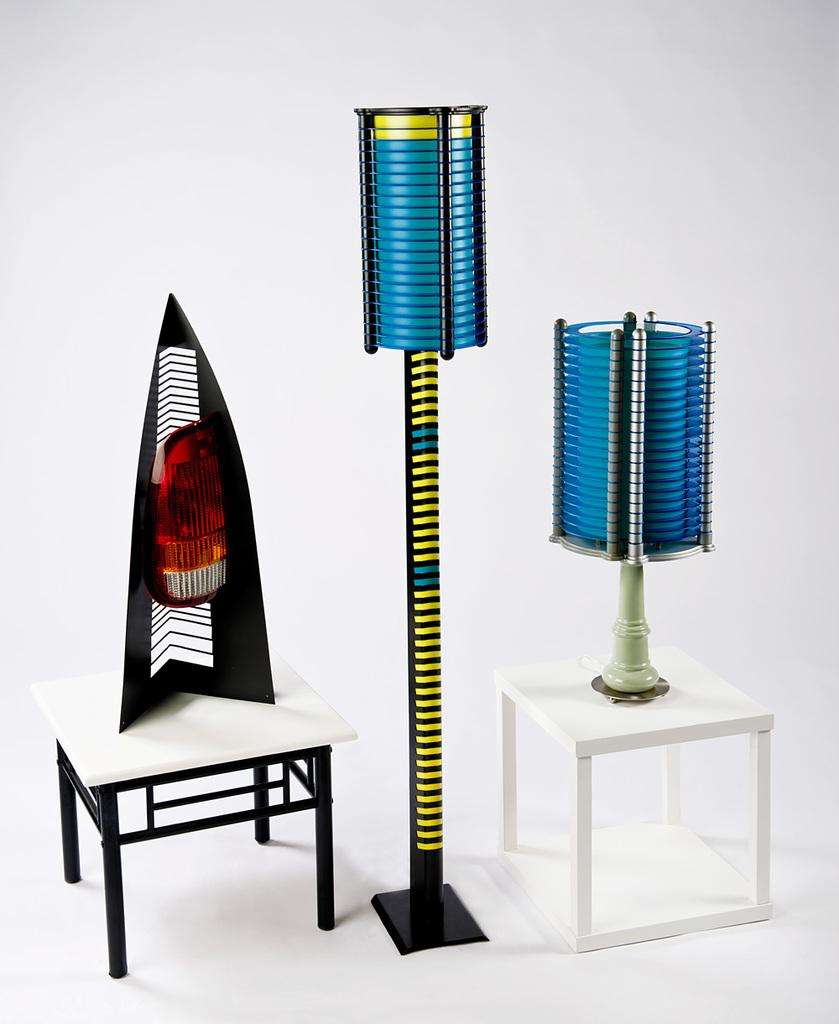What type of furniture is located on the right side of the image? There are stools on the right side of the image. Are there any stools on the left side of the image? Yes, there are stools on the left side of the image as well. What is placed on the stools? There are objects on the stools. What can be seen in the center of the image? There is a pole in the center of the image. What color is the background of the image? The background of the image is white in color. What type of cart is used to transport the objects on the stools in the image? There is no cart present in the image; the objects are placed directly on the stools. What scientific theory is being discussed in the image? There is no discussion of a scientific theory in the image; it features stools, a pole, and objects on the stools. 